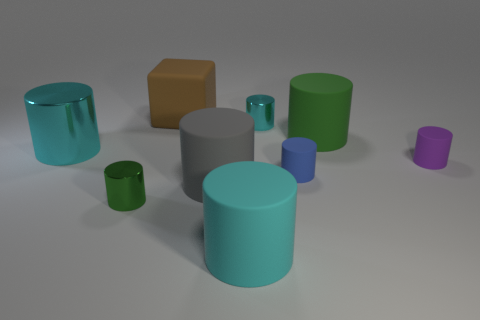Are there more big objects to the left of the tiny cyan object than purple shiny cylinders?
Make the answer very short. Yes. How many other things are there of the same color as the rubber cube?
Offer a very short reply. 0. Does the green cylinder that is behind the purple cylinder have the same size as the small cyan metallic cylinder?
Your answer should be compact. No. Are there any green things that have the same size as the green rubber cylinder?
Your answer should be compact. No. What is the color of the small metallic thing in front of the purple matte cylinder?
Provide a short and direct response. Green. What shape is the matte thing that is on the left side of the small blue matte cylinder and behind the large gray matte cylinder?
Offer a very short reply. Cube. How many tiny green objects are the same shape as the tiny cyan metallic object?
Ensure brevity in your answer.  1. How many gray cylinders are there?
Make the answer very short. 1. How big is the metallic cylinder that is right of the big cyan shiny thing and behind the green metal object?
Give a very brief answer. Small. What is the shape of the brown object that is the same size as the gray cylinder?
Provide a short and direct response. Cube. 